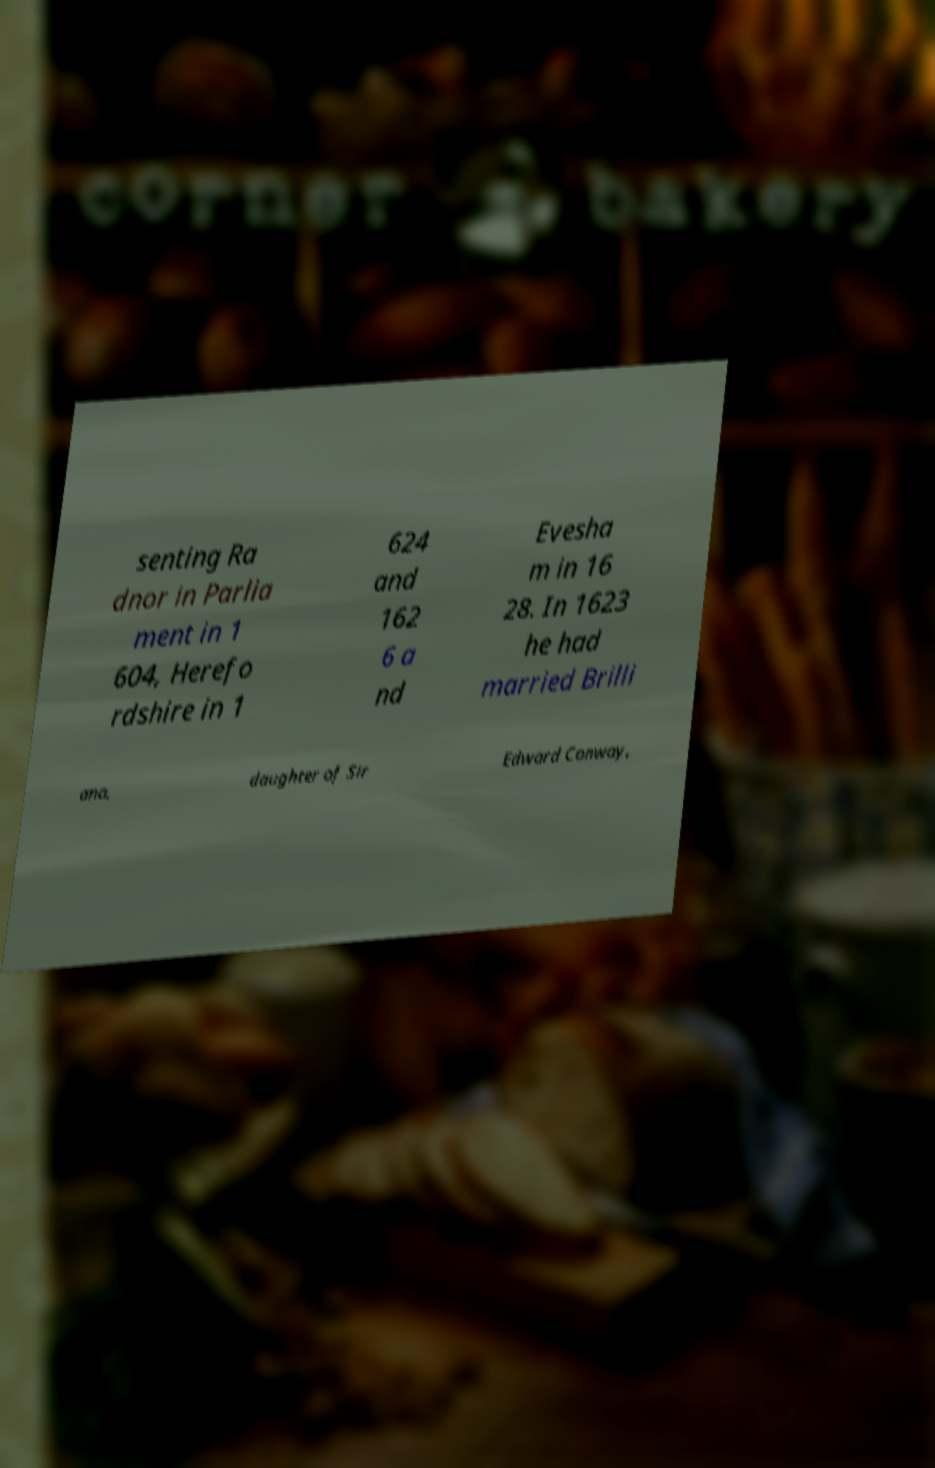Could you assist in decoding the text presented in this image and type it out clearly? senting Ra dnor in Parlia ment in 1 604, Herefo rdshire in 1 624 and 162 6 a nd Evesha m in 16 28. In 1623 he had married Brilli ana, daughter of Sir Edward Conway, 